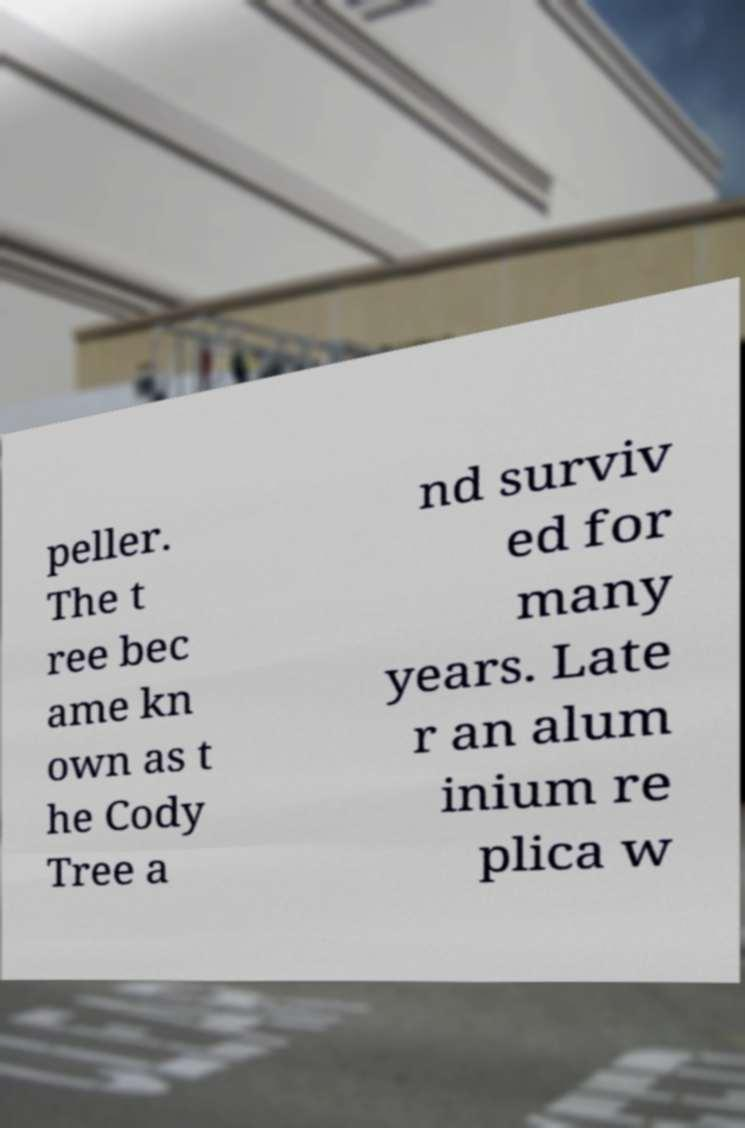Please identify and transcribe the text found in this image. peller. The t ree bec ame kn own as t he Cody Tree a nd surviv ed for many years. Late r an alum inium re plica w 